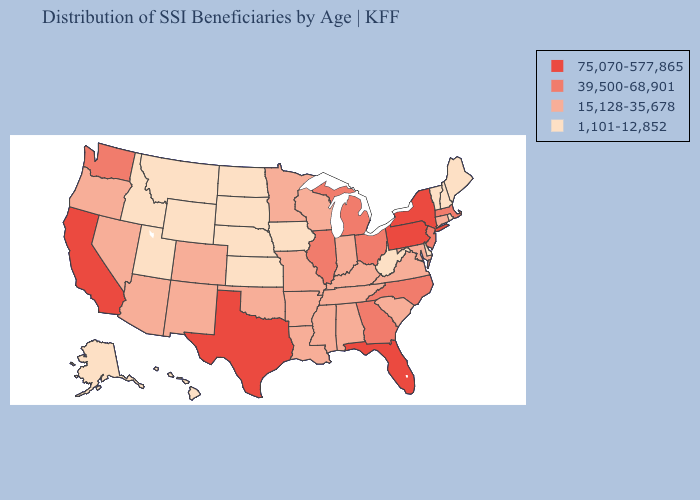Among the states that border Kansas , does Colorado have the lowest value?
Write a very short answer. No. Name the states that have a value in the range 39,500-68,901?
Give a very brief answer. Georgia, Illinois, Massachusetts, Michigan, New Jersey, North Carolina, Ohio, Washington. Name the states that have a value in the range 15,128-35,678?
Be succinct. Alabama, Arizona, Arkansas, Colorado, Connecticut, Indiana, Kentucky, Louisiana, Maryland, Minnesota, Mississippi, Missouri, Nevada, New Mexico, Oklahoma, Oregon, South Carolina, Tennessee, Virginia, Wisconsin. Does Indiana have the highest value in the MidWest?
Short answer required. No. Name the states that have a value in the range 1,101-12,852?
Be succinct. Alaska, Delaware, Hawaii, Idaho, Iowa, Kansas, Maine, Montana, Nebraska, New Hampshire, North Dakota, Rhode Island, South Dakota, Utah, Vermont, West Virginia, Wyoming. Name the states that have a value in the range 75,070-577,865?
Give a very brief answer. California, Florida, New York, Pennsylvania, Texas. Which states have the lowest value in the West?
Short answer required. Alaska, Hawaii, Idaho, Montana, Utah, Wyoming. Name the states that have a value in the range 1,101-12,852?
Keep it brief. Alaska, Delaware, Hawaii, Idaho, Iowa, Kansas, Maine, Montana, Nebraska, New Hampshire, North Dakota, Rhode Island, South Dakota, Utah, Vermont, West Virginia, Wyoming. Does Hawaii have the lowest value in the West?
Short answer required. Yes. Name the states that have a value in the range 39,500-68,901?
Give a very brief answer. Georgia, Illinois, Massachusetts, Michigan, New Jersey, North Carolina, Ohio, Washington. Name the states that have a value in the range 1,101-12,852?
Be succinct. Alaska, Delaware, Hawaii, Idaho, Iowa, Kansas, Maine, Montana, Nebraska, New Hampshire, North Dakota, Rhode Island, South Dakota, Utah, Vermont, West Virginia, Wyoming. What is the value of Kansas?
Concise answer only. 1,101-12,852. Does California have the highest value in the West?
Concise answer only. Yes. How many symbols are there in the legend?
Write a very short answer. 4. What is the value of Mississippi?
Short answer required. 15,128-35,678. 